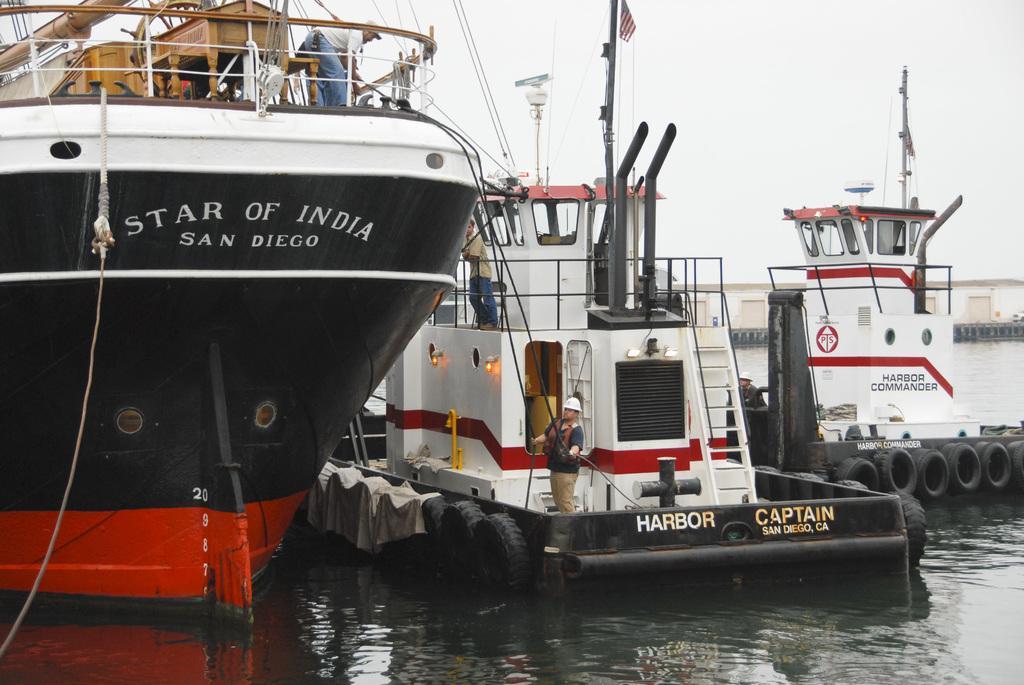How would you summarize this image in a sentence or two? In this image we can see a ship, here a person is standing, here is the rope, here are some objects in it, here is the boat, here are the tires, here is the light, here is the flag, here is the water, at above here is the sky. 